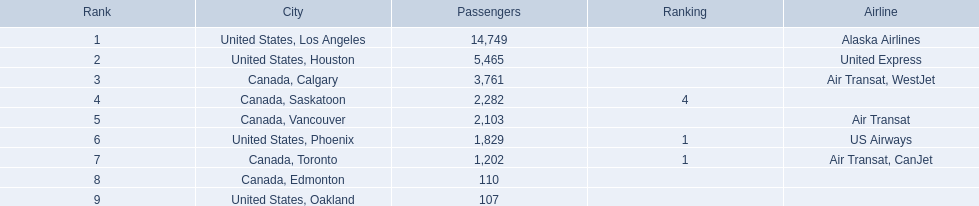What metropolises do the airplanes go to? United States, Los Angeles, United States, Houston, Canada, Calgary, Canada, Saskatoon, Canada, Vancouver, United States, Phoenix, Canada, Toronto, Canada, Edmonton, United States, Oakland. How many passengers are heading to phoenix, arizona? 1,829. 